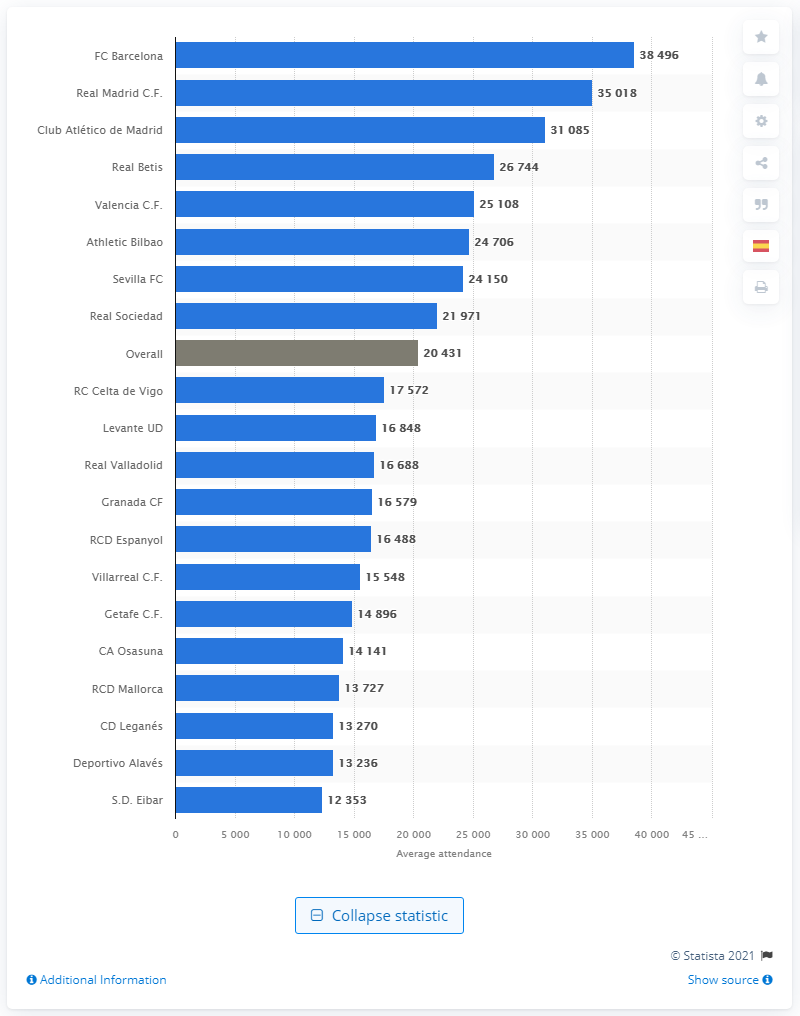Identify some key points in this picture. Real Madrid received 35,018 live fans during the 2019/2020 season. 